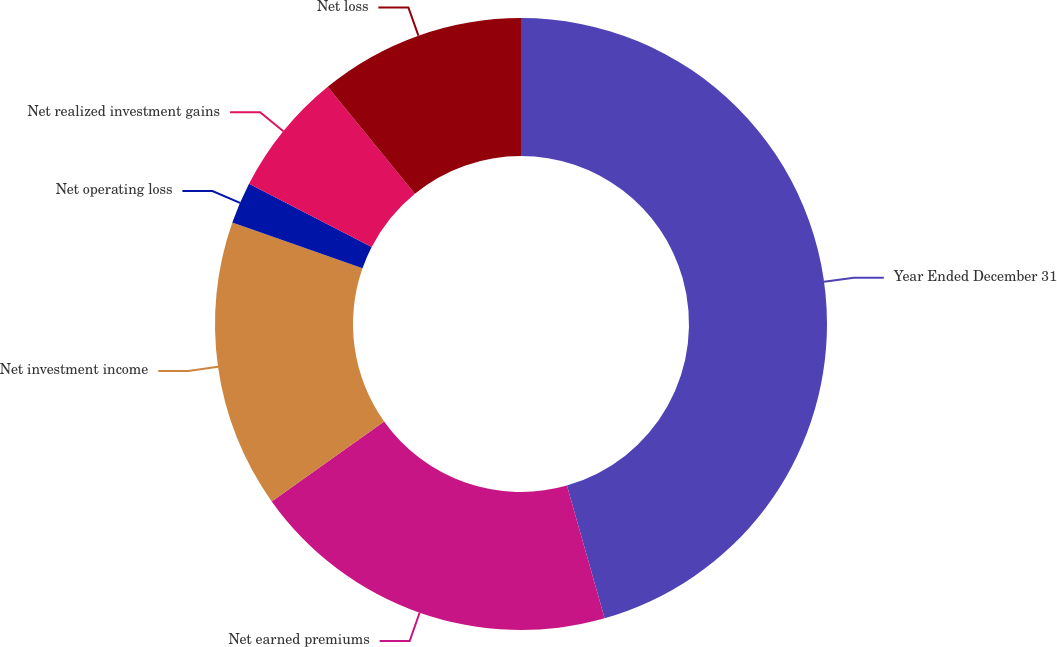Convert chart to OTSL. <chart><loc_0><loc_0><loc_500><loc_500><pie_chart><fcel>Year Ended December 31<fcel>Net earned premiums<fcel>Net investment income<fcel>Net operating loss<fcel>Net realized investment gains<fcel>Net loss<nl><fcel>45.59%<fcel>19.56%<fcel>15.22%<fcel>2.2%<fcel>6.54%<fcel>10.88%<nl></chart> 